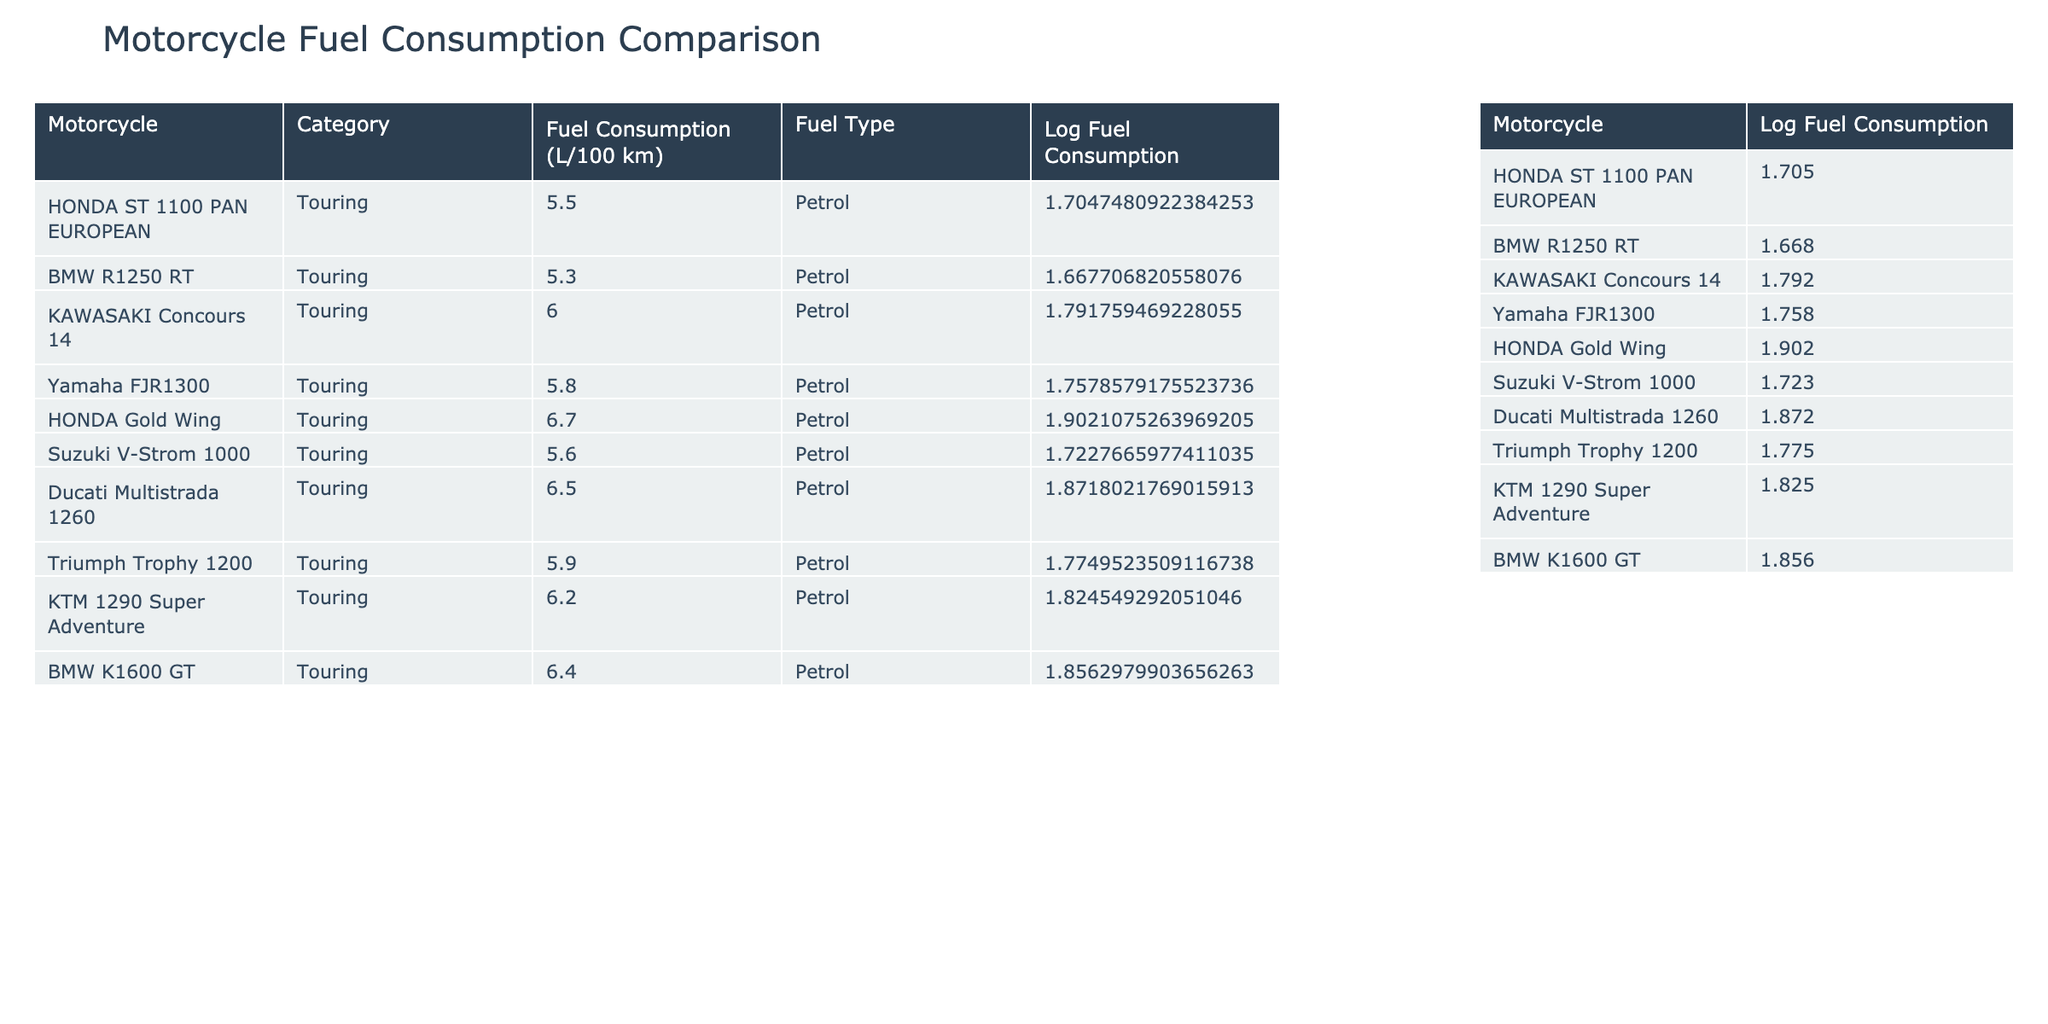What is the fuel consumption of the Honda Gold Wing? According to the table, the fuel consumption for the Honda Gold Wing is listed as 6.7 L/100 km.
Answer: 6.7 L/100 km Which motorcycle has the lowest fuel consumption among the listed models? The BMW R1250 RT has the lowest fuel consumption at 5.3 L/100 km, which can be directly observed in the table.
Answer: BMW R1250 RT What is the average fuel consumption of the motorcycles listed, excluding the Honda ST 1100? To calculate the average, first sum the fuel consumption of the other motorcycles: (5.3 + 6.0 + 5.8 + 6.7 + 5.6 + 6.5 + 5.9 + 6.2 + 6.4) = 52.0. There are 9 motorcycles, so the average is 52.0 / 9 ≈ 5.78 L/100 km.
Answer: 5.78 L/100 km Is it true that both the Honda ST 1100 and the Yamaha FJR1300 have fuel consumption values below 6.0 L/100 km? The Honda ST 1100 has a consumption of 5.5 L/100 km and the Yamaha FJR1300 has 5.8 L/100 km, both below 6.0 L/100 km. Thus, the statement is true.
Answer: Yes What is the difference in fuel consumption between the most fuel-efficient motorcycle and the least fuel-efficient motorcycle? The most fuel-efficient motorcycle is the BMW R1250 RT (5.3 L/100 km) and the least fuel-efficient is the Honda Gold Wing (6.7 L/100 km). The difference is 6.7 - 5.3 = 1.4 L/100 km.
Answer: 1.4 L/100 km How many motorcycles have a fuel consumption greater than 6.0 L/100 km? From the table, the motorcycles with fuel consumption greater than 6.0 L/100 km are the Honda Gold Wing, Ducati Multistrada 1260, KTM 1290 Super Adventure, and BMW K1600 GT. There are 4 such motorcycles.
Answer: 4 What is the total fuel consumption of all the motorcycles listed in the table? Add all the fuel consumption values together: 5.5 + 5.3 + 6.0 + 5.8 + 6.7 + 5.6 + 6.5 + 5.9 + 6.2 + 6.4 = 60.0 L/100 km.
Answer: 60.0 L/100 km Does the Ducati Multistrada 1260 consume more fuel than the HONDA ST 1100 PAN EUROPEAN? The Ducati Multistrada 1260 has a consumption of 6.5 L/100 km, while the Honda ST 1100 has 5.5 L/100 km, making it true that the Ducati consumes more.
Answer: Yes 